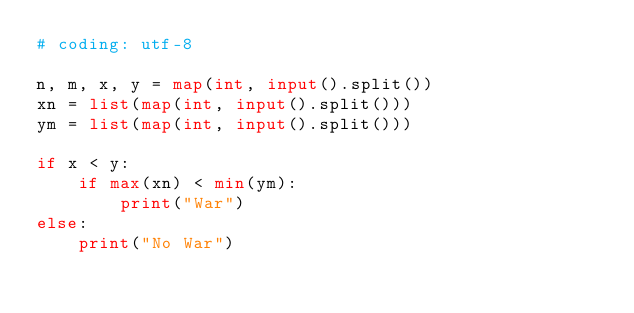<code> <loc_0><loc_0><loc_500><loc_500><_Python_># coding: utf-8
 
n, m, x, y = map(int, input().split())
xn = list(map(int, input().split()))
ym = list(map(int, input().split()))
 
if x < y:
    if max(xn) < min(ym):
        print("War")
else:
    print("No War")</code> 